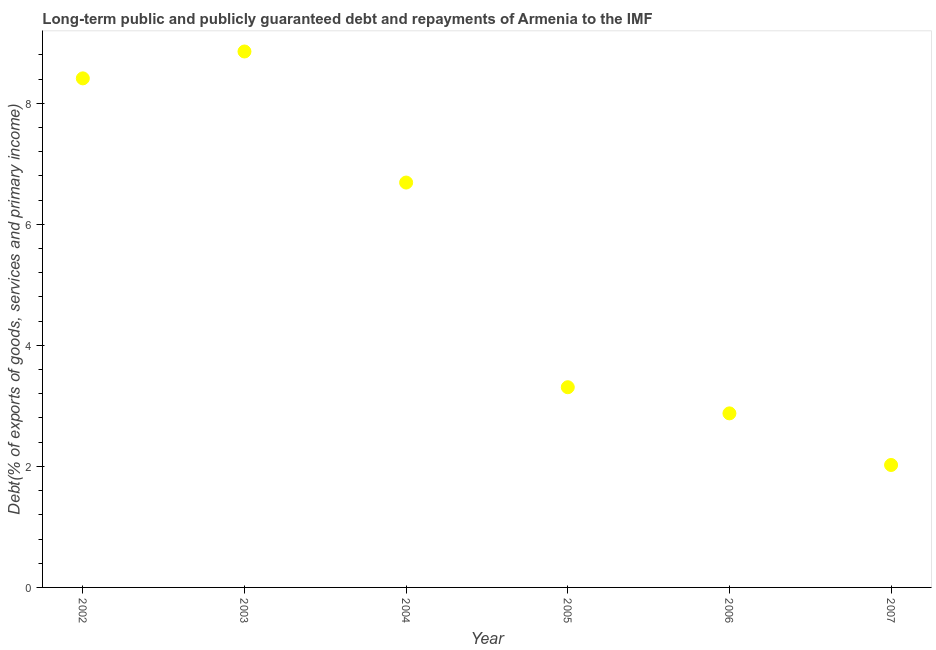What is the debt service in 2007?
Provide a succinct answer. 2.02. Across all years, what is the maximum debt service?
Ensure brevity in your answer.  8.86. Across all years, what is the minimum debt service?
Provide a short and direct response. 2.02. In which year was the debt service minimum?
Ensure brevity in your answer.  2007. What is the sum of the debt service?
Provide a succinct answer. 32.16. What is the difference between the debt service in 2005 and 2007?
Your answer should be compact. 1.28. What is the average debt service per year?
Your answer should be compact. 5.36. What is the median debt service?
Your response must be concise. 5. What is the ratio of the debt service in 2003 to that in 2005?
Provide a short and direct response. 2.68. What is the difference between the highest and the second highest debt service?
Provide a succinct answer. 0.44. What is the difference between the highest and the lowest debt service?
Your response must be concise. 6.83. In how many years, is the debt service greater than the average debt service taken over all years?
Make the answer very short. 3. How many dotlines are there?
Your answer should be compact. 1. What is the difference between two consecutive major ticks on the Y-axis?
Ensure brevity in your answer.  2. Are the values on the major ticks of Y-axis written in scientific E-notation?
Offer a very short reply. No. Does the graph contain grids?
Give a very brief answer. No. What is the title of the graph?
Provide a succinct answer. Long-term public and publicly guaranteed debt and repayments of Armenia to the IMF. What is the label or title of the X-axis?
Your answer should be very brief. Year. What is the label or title of the Y-axis?
Provide a succinct answer. Debt(% of exports of goods, services and primary income). What is the Debt(% of exports of goods, services and primary income) in 2002?
Make the answer very short. 8.41. What is the Debt(% of exports of goods, services and primary income) in 2003?
Your response must be concise. 8.86. What is the Debt(% of exports of goods, services and primary income) in 2004?
Your response must be concise. 6.69. What is the Debt(% of exports of goods, services and primary income) in 2005?
Provide a short and direct response. 3.31. What is the Debt(% of exports of goods, services and primary income) in 2006?
Keep it short and to the point. 2.88. What is the Debt(% of exports of goods, services and primary income) in 2007?
Keep it short and to the point. 2.02. What is the difference between the Debt(% of exports of goods, services and primary income) in 2002 and 2003?
Keep it short and to the point. -0.44. What is the difference between the Debt(% of exports of goods, services and primary income) in 2002 and 2004?
Offer a terse response. 1.72. What is the difference between the Debt(% of exports of goods, services and primary income) in 2002 and 2005?
Make the answer very short. 5.1. What is the difference between the Debt(% of exports of goods, services and primary income) in 2002 and 2006?
Your response must be concise. 5.54. What is the difference between the Debt(% of exports of goods, services and primary income) in 2002 and 2007?
Provide a short and direct response. 6.39. What is the difference between the Debt(% of exports of goods, services and primary income) in 2003 and 2004?
Your answer should be compact. 2.17. What is the difference between the Debt(% of exports of goods, services and primary income) in 2003 and 2005?
Keep it short and to the point. 5.55. What is the difference between the Debt(% of exports of goods, services and primary income) in 2003 and 2006?
Ensure brevity in your answer.  5.98. What is the difference between the Debt(% of exports of goods, services and primary income) in 2003 and 2007?
Your response must be concise. 6.83. What is the difference between the Debt(% of exports of goods, services and primary income) in 2004 and 2005?
Keep it short and to the point. 3.38. What is the difference between the Debt(% of exports of goods, services and primary income) in 2004 and 2006?
Provide a succinct answer. 3.81. What is the difference between the Debt(% of exports of goods, services and primary income) in 2004 and 2007?
Your response must be concise. 4.67. What is the difference between the Debt(% of exports of goods, services and primary income) in 2005 and 2006?
Your answer should be compact. 0.43. What is the difference between the Debt(% of exports of goods, services and primary income) in 2005 and 2007?
Your response must be concise. 1.28. What is the difference between the Debt(% of exports of goods, services and primary income) in 2006 and 2007?
Your answer should be very brief. 0.85. What is the ratio of the Debt(% of exports of goods, services and primary income) in 2002 to that in 2004?
Make the answer very short. 1.26. What is the ratio of the Debt(% of exports of goods, services and primary income) in 2002 to that in 2005?
Your response must be concise. 2.54. What is the ratio of the Debt(% of exports of goods, services and primary income) in 2002 to that in 2006?
Ensure brevity in your answer.  2.92. What is the ratio of the Debt(% of exports of goods, services and primary income) in 2002 to that in 2007?
Make the answer very short. 4.16. What is the ratio of the Debt(% of exports of goods, services and primary income) in 2003 to that in 2004?
Keep it short and to the point. 1.32. What is the ratio of the Debt(% of exports of goods, services and primary income) in 2003 to that in 2005?
Your response must be concise. 2.68. What is the ratio of the Debt(% of exports of goods, services and primary income) in 2003 to that in 2006?
Keep it short and to the point. 3.08. What is the ratio of the Debt(% of exports of goods, services and primary income) in 2003 to that in 2007?
Keep it short and to the point. 4.38. What is the ratio of the Debt(% of exports of goods, services and primary income) in 2004 to that in 2005?
Your response must be concise. 2.02. What is the ratio of the Debt(% of exports of goods, services and primary income) in 2004 to that in 2006?
Provide a succinct answer. 2.33. What is the ratio of the Debt(% of exports of goods, services and primary income) in 2004 to that in 2007?
Your answer should be compact. 3.31. What is the ratio of the Debt(% of exports of goods, services and primary income) in 2005 to that in 2006?
Give a very brief answer. 1.15. What is the ratio of the Debt(% of exports of goods, services and primary income) in 2005 to that in 2007?
Offer a very short reply. 1.64. What is the ratio of the Debt(% of exports of goods, services and primary income) in 2006 to that in 2007?
Keep it short and to the point. 1.42. 